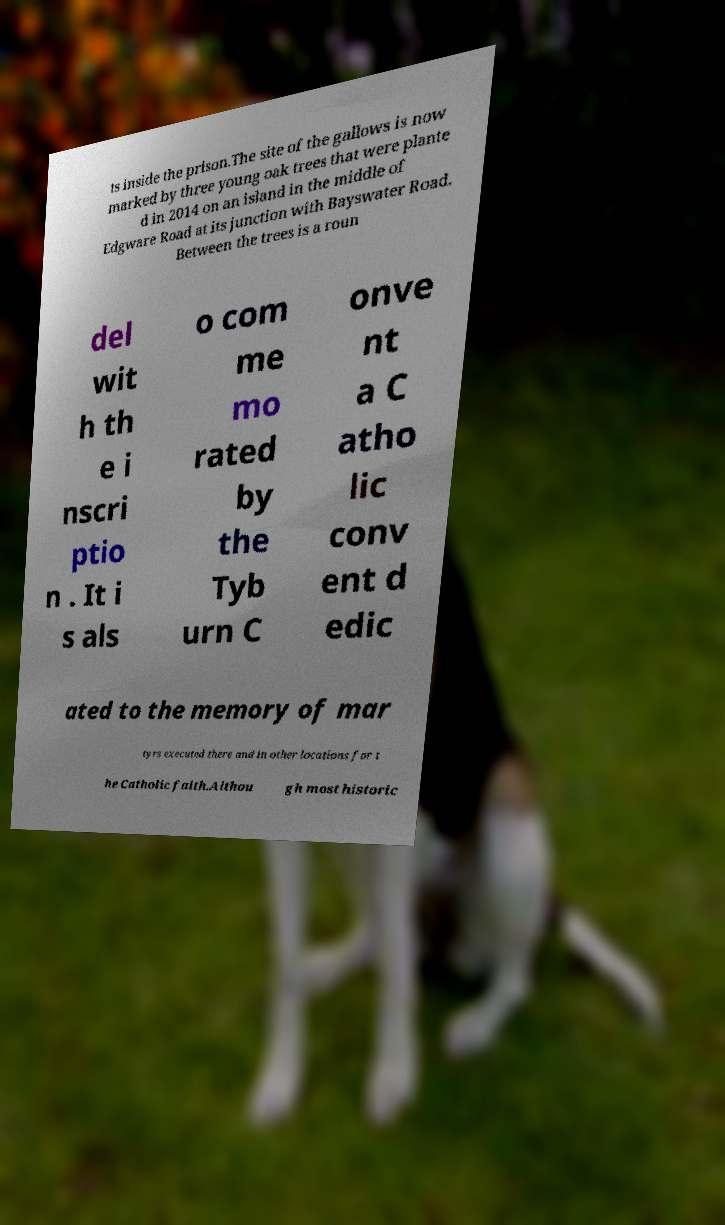What messages or text are displayed in this image? I need them in a readable, typed format. ts inside the prison.The site of the gallows is now marked by three young oak trees that were plante d in 2014 on an island in the middle of Edgware Road at its junction with Bayswater Road. Between the trees is a roun del wit h th e i nscri ptio n . It i s als o com me mo rated by the Tyb urn C onve nt a C atho lic conv ent d edic ated to the memory of mar tyrs executed there and in other locations for t he Catholic faith.Althou gh most historic 